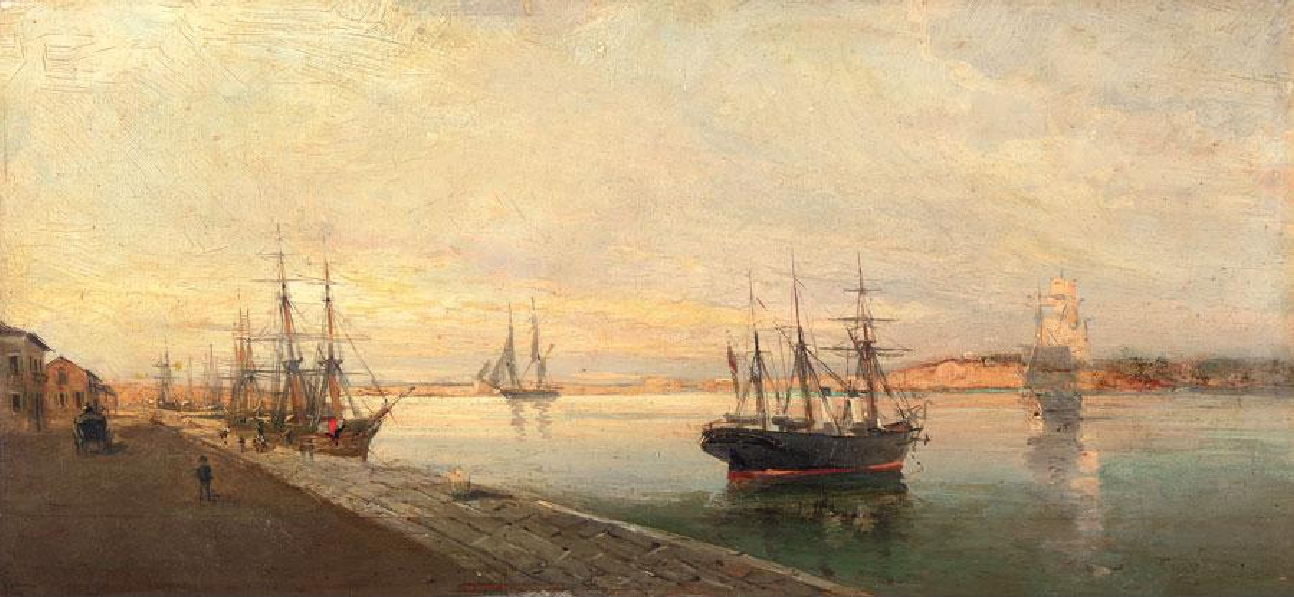Can you tell me more about the ships in the image? What do they indicate about the time period or location? The ships in the image are tall sailing ships, most likely to be merchant ships or barques, which were common from the 18th to the early 20th century. Their presence indicates that this scene is set in a time before the widespread use of steam power, when wind and sails were the primary means of maritime navigation. The design of these vessels, with their multiple masts and rigged sails, suggests a European harbor, as this style was particularly prevalent in European maritime trade during that era. The precise rigging and the robust hulls convey a sense of the sailing expertise and the naval architecture that was characteristic of the time, reflecting both the technological advances of the age and the reliance on the sea for commerce and exploration. 